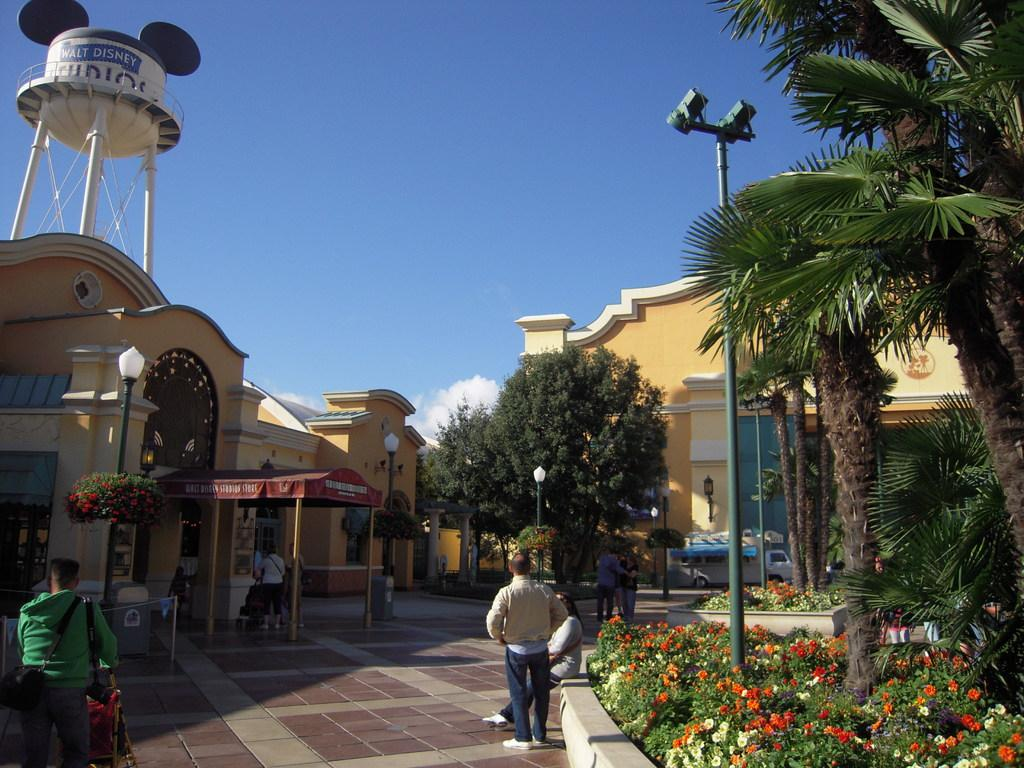What type of structures can be seen in the image? There are buildings in the image. What natural elements are present in the image? There are trees and plants in the image. What type of lighting is present in the image? There are street lamps in the image. Are there any living beings visible in the image? Yes, there are people visible in the image. What part of the natural environment is visible in the image? The sky is visible at the top of the image. What type of bells can be heard ringing in the image? There are no bells present in the image, and therefore no sound can be heard. Is there any blood visible on the people in the image? There is no blood visible on the people in the image. 